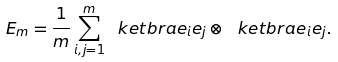<formula> <loc_0><loc_0><loc_500><loc_500>E _ { m } = \frac { 1 } { m } \sum _ { i , j = 1 } ^ { m } \ k e t b r a { e _ { i } } { e _ { j } } \otimes \ k e t b r a { e _ { i } } { e _ { j } } .</formula> 